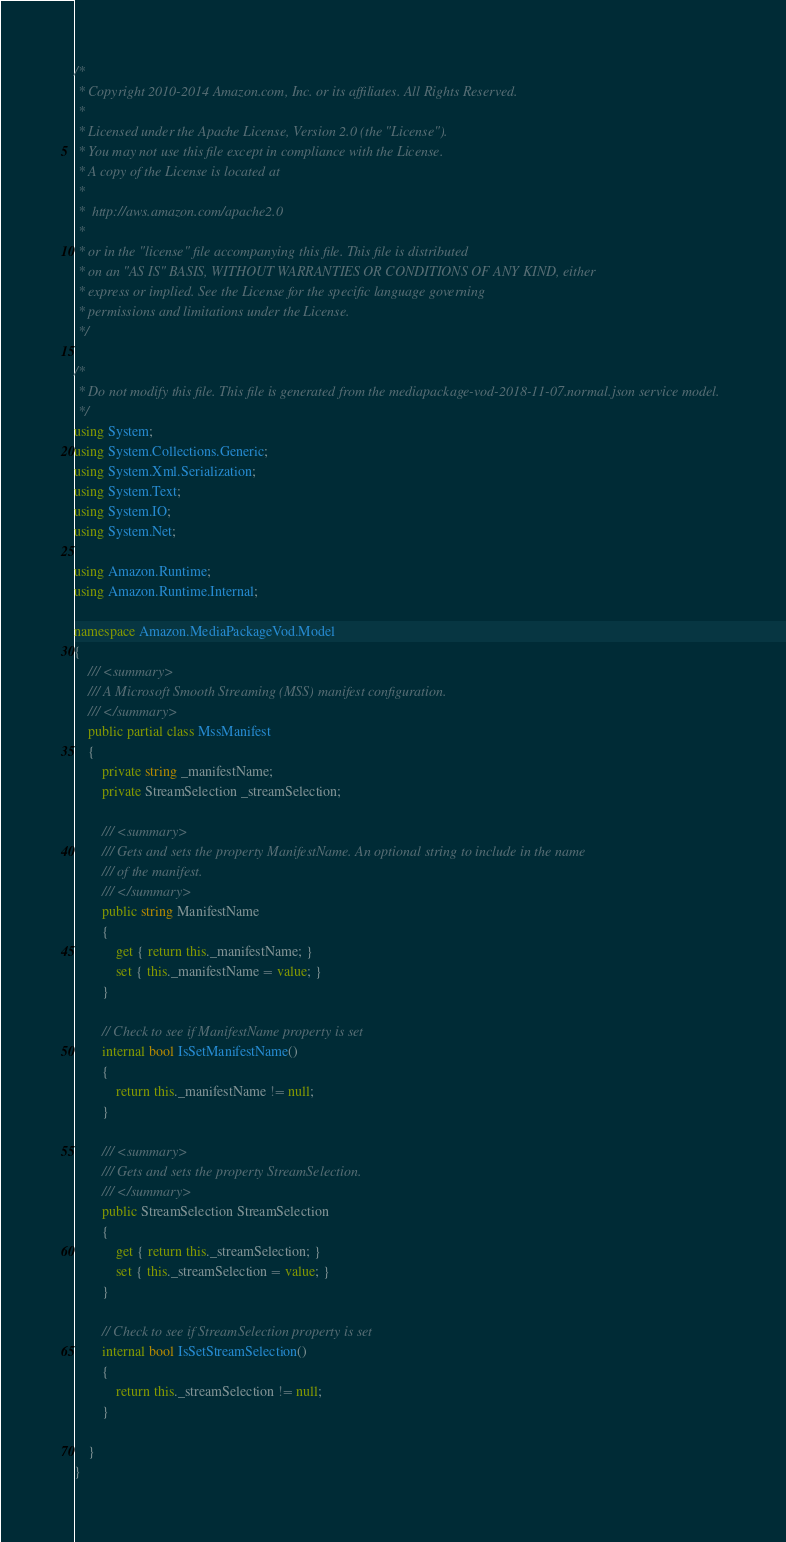Convert code to text. <code><loc_0><loc_0><loc_500><loc_500><_C#_>/*
 * Copyright 2010-2014 Amazon.com, Inc. or its affiliates. All Rights Reserved.
 * 
 * Licensed under the Apache License, Version 2.0 (the "License").
 * You may not use this file except in compliance with the License.
 * A copy of the License is located at
 * 
 *  http://aws.amazon.com/apache2.0
 * 
 * or in the "license" file accompanying this file. This file is distributed
 * on an "AS IS" BASIS, WITHOUT WARRANTIES OR CONDITIONS OF ANY KIND, either
 * express or implied. See the License for the specific language governing
 * permissions and limitations under the License.
 */

/*
 * Do not modify this file. This file is generated from the mediapackage-vod-2018-11-07.normal.json service model.
 */
using System;
using System.Collections.Generic;
using System.Xml.Serialization;
using System.Text;
using System.IO;
using System.Net;

using Amazon.Runtime;
using Amazon.Runtime.Internal;

namespace Amazon.MediaPackageVod.Model
{
    /// <summary>
    /// A Microsoft Smooth Streaming (MSS) manifest configuration.
    /// </summary>
    public partial class MssManifest
    {
        private string _manifestName;
        private StreamSelection _streamSelection;

        /// <summary>
        /// Gets and sets the property ManifestName. An optional string to include in the name
        /// of the manifest.
        /// </summary>
        public string ManifestName
        {
            get { return this._manifestName; }
            set { this._manifestName = value; }
        }

        // Check to see if ManifestName property is set
        internal bool IsSetManifestName()
        {
            return this._manifestName != null;
        }

        /// <summary>
        /// Gets and sets the property StreamSelection.
        /// </summary>
        public StreamSelection StreamSelection
        {
            get { return this._streamSelection; }
            set { this._streamSelection = value; }
        }

        // Check to see if StreamSelection property is set
        internal bool IsSetStreamSelection()
        {
            return this._streamSelection != null;
        }

    }
}</code> 